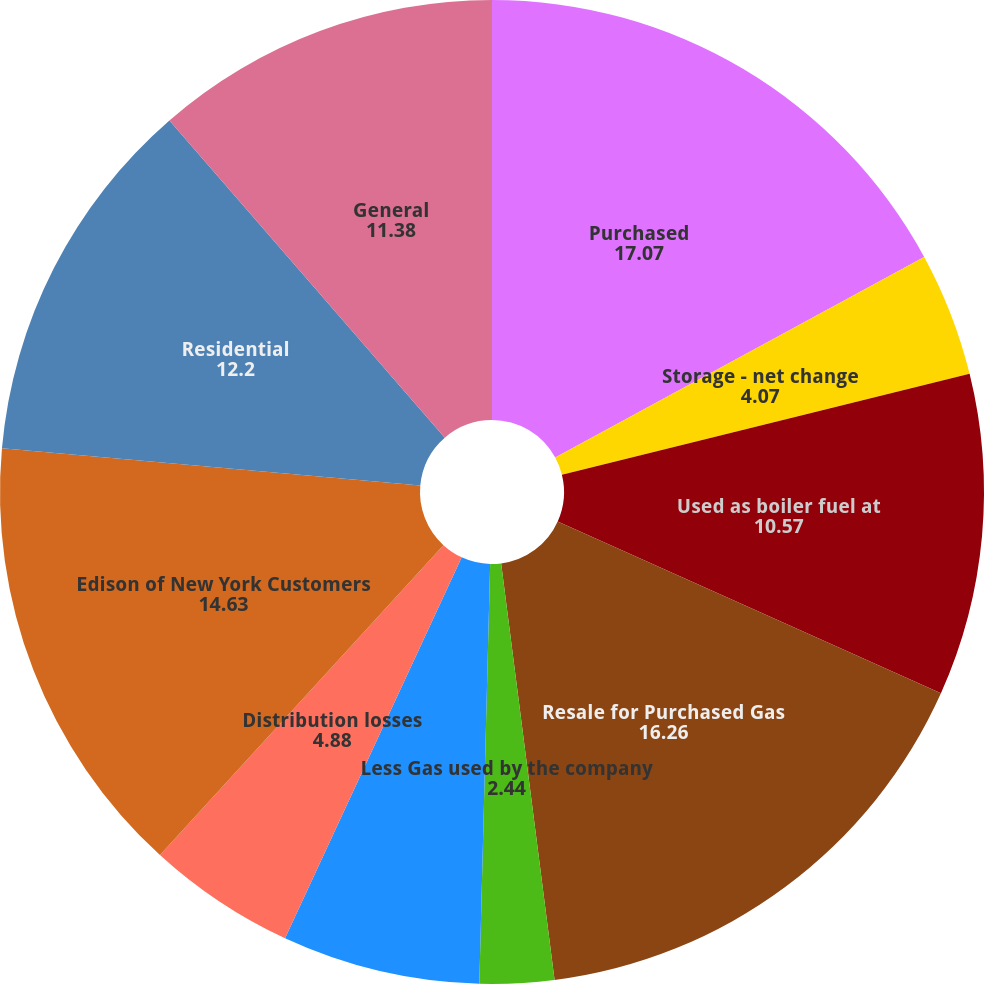Convert chart. <chart><loc_0><loc_0><loc_500><loc_500><pie_chart><fcel>Purchased<fcel>Storage - net change<fcel>Used as boiler fuel at<fcel>Resale for Purchased Gas<fcel>Less Gas used by the company<fcel>Off-System Sales NYPA and<fcel>Distribution losses<fcel>Edison of New York Customers<fcel>Residential<fcel>General<nl><fcel>17.07%<fcel>4.07%<fcel>10.57%<fcel>16.26%<fcel>2.44%<fcel>6.5%<fcel>4.88%<fcel>14.63%<fcel>12.2%<fcel>11.38%<nl></chart> 